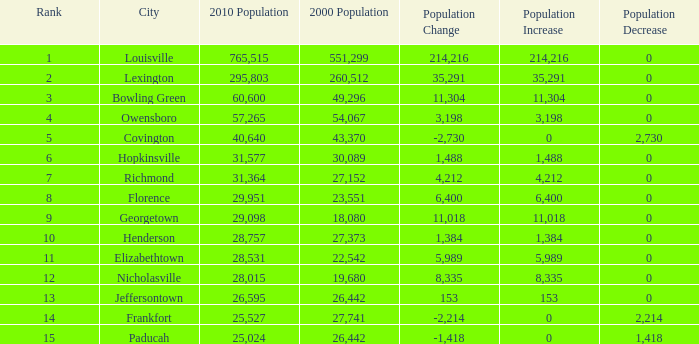What was the 2010 population of frankfort which has a rank smaller than 14? None. 